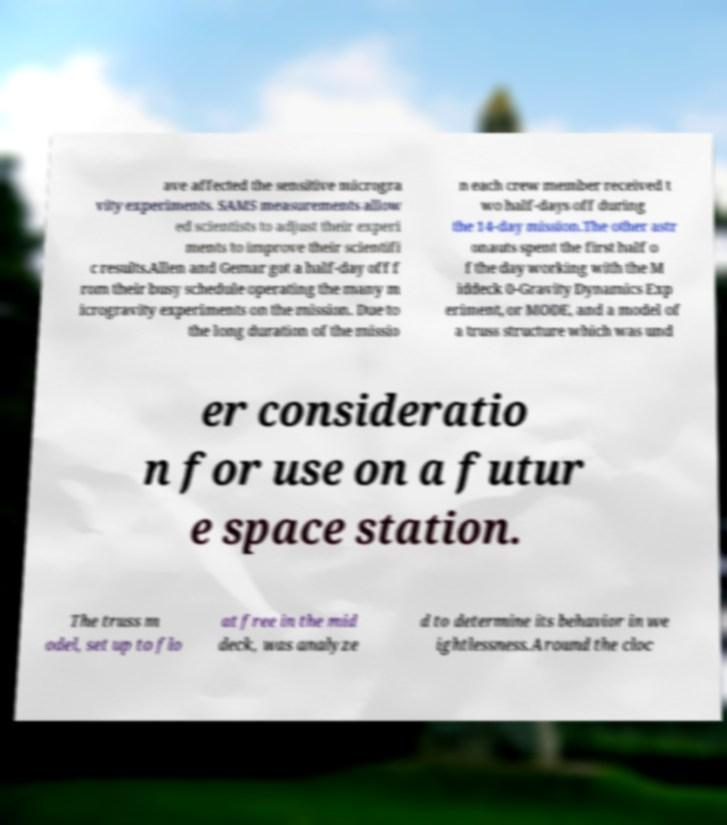There's text embedded in this image that I need extracted. Can you transcribe it verbatim? ave affected the sensitive microgra vity experiments. SAMS measurements allow ed scientists to adjust their experi ments to improve their scientifi c results.Allen and Gemar got a half-day off f rom their busy schedule operating the many m icrogravity experiments on the mission. Due to the long duration of the missio n each crew member received t wo half-days off during the 14-day mission.The other astr onauts spent the first half o f the day working with the M iddeck 0-Gravity Dynamics Exp eriment, or MODE, and a model of a truss structure which was und er consideratio n for use on a futur e space station. The truss m odel, set up to flo at free in the mid deck, was analyze d to determine its behavior in we ightlessness.Around the cloc 